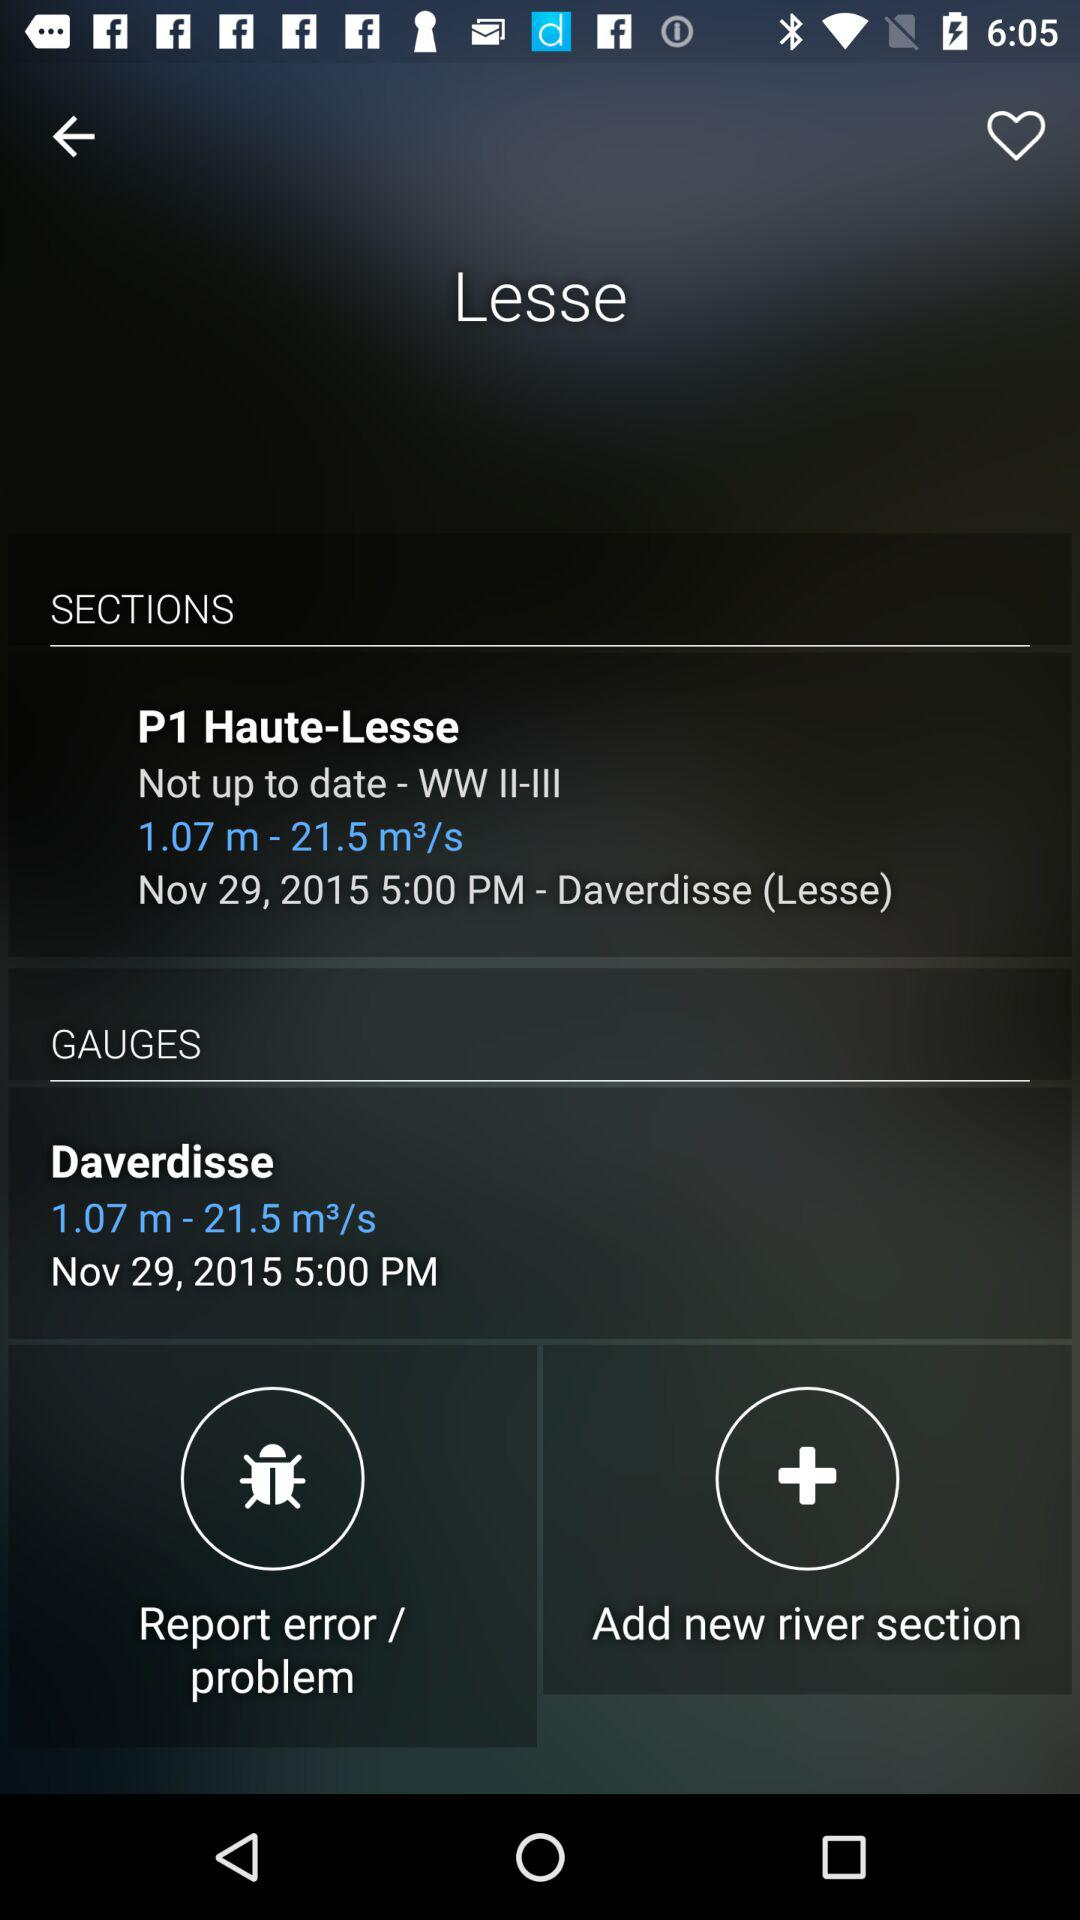On what date was Daverdisse updated? Daverdisse was updated on November 29, 2015. 